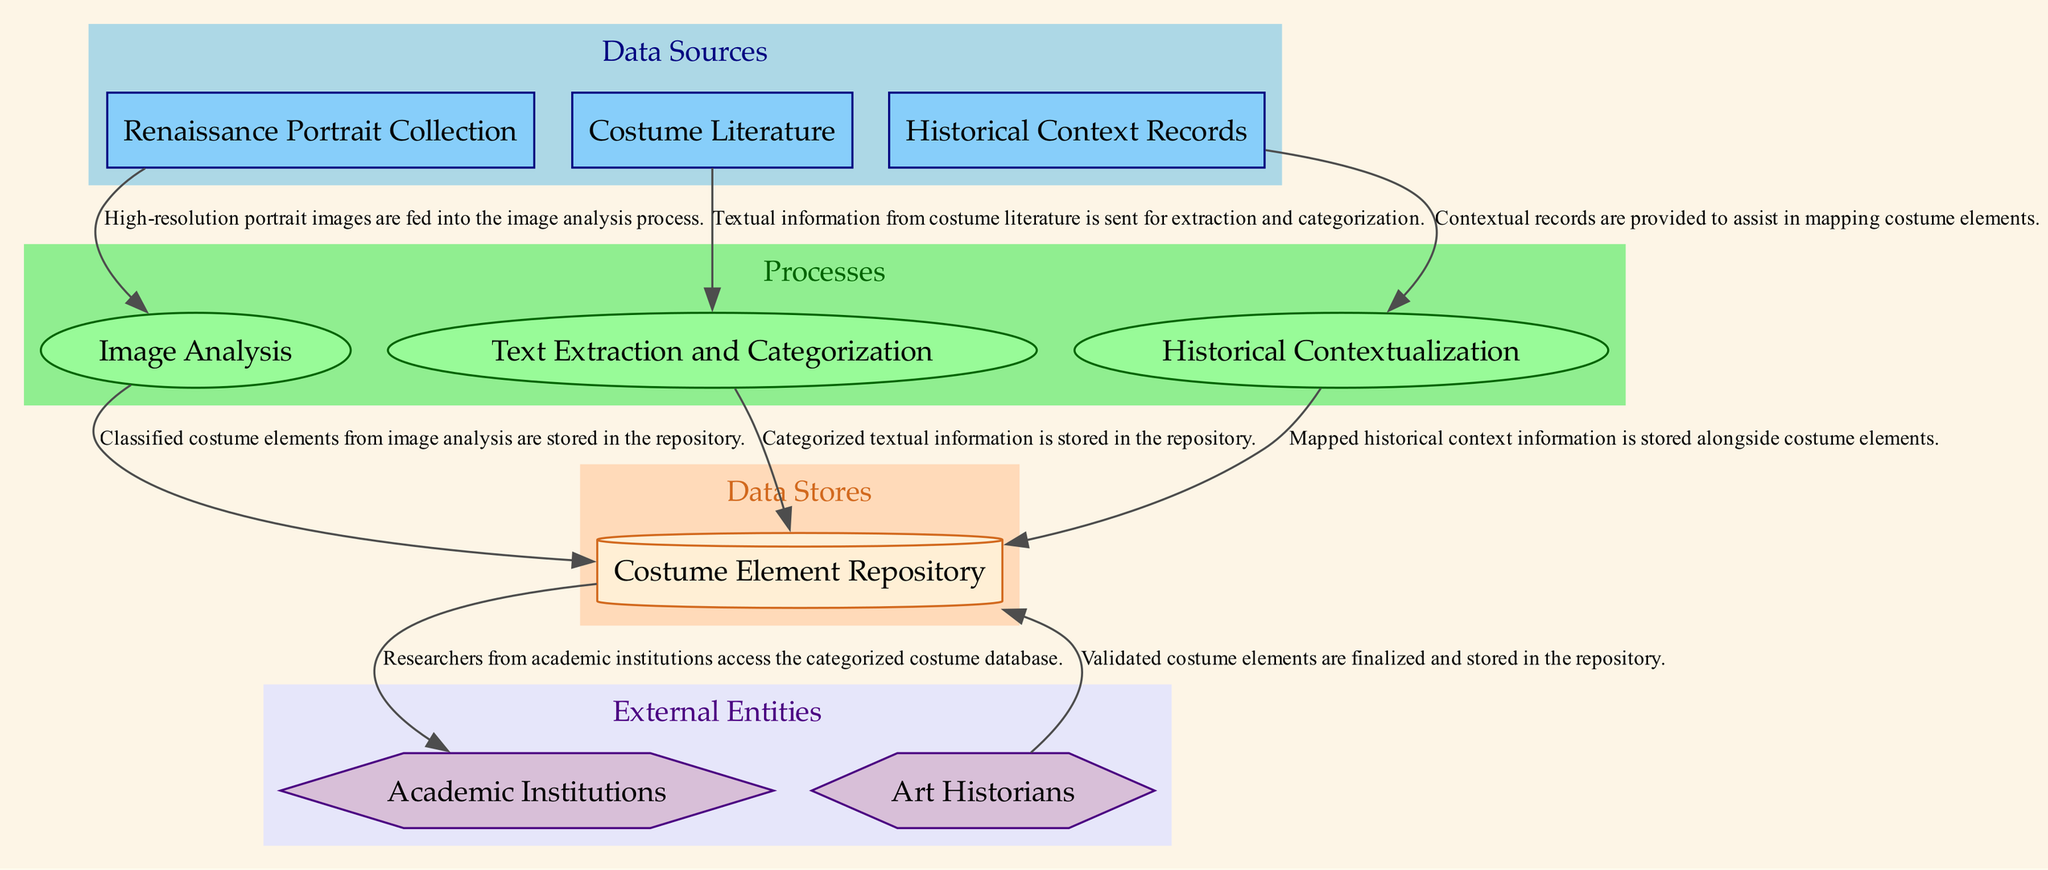What are the three data sources in the diagram? The diagram lists the following data sources: "Renaissance Portrait Collection," "Costume Literature," and "Historical Context Records." These are explicitly mentioned in the data sources section of the diagram.
Answer: Renaissance Portrait Collection, Costume Literature, Historical Context Records How many processes are depicted in the diagram? The diagram shows three processes: "Image Analysis," "Text Extraction and Categorization," and "Historical Contextualization." By counting the nodes in the processes section, we find there are three.
Answer: Three Which process receives input from the Historical Context Records? The "Historical Contextualization" process is the one that directly receives data from the Historical Context Records, as indicated by the associated data flow in the diagram.
Answer: Historical Contextualization What type of external entity is identified in the diagram? The diagram identifies two external entities: "Art Historians," categorized as a user, and "Academic Institutions," categorized as an entity. Thus, the type includes both users and entities.
Answer: User and Entity From which processes is data stored in the Costume Element Repository? Data is stored in the Costume Element Repository from three processes: "Image Analysis," "Text Extraction and Categorization," and "Historical Contextualization." Each of these processes has a defined outgoing data flow to this repository.
Answer: Image Analysis, Text Extraction and Categorization, Historical Contextualization What does the dashed line to the Costume Element Repository signify? The diagram indicates that validated costume elements come from Art Historians into the Costume Element Repository. This flow highlights the process of validation before final storage.
Answer: Validation flow How do academic institutions interact with the Costume Element Repository? Academic Institutions access the Costume Element Repository to retrieve categorized costume data. This is illustrated by a direct data flow from the repository to the institutions.
Answer: They access it for research Which node has the role of mapping historical data to costume elements? The "Historical Contextualization" process is responsible for mapping historical context records to costume elements, as shown by the incoming flow from Historical Context Records to this process.
Answer: Historical Contextualization 